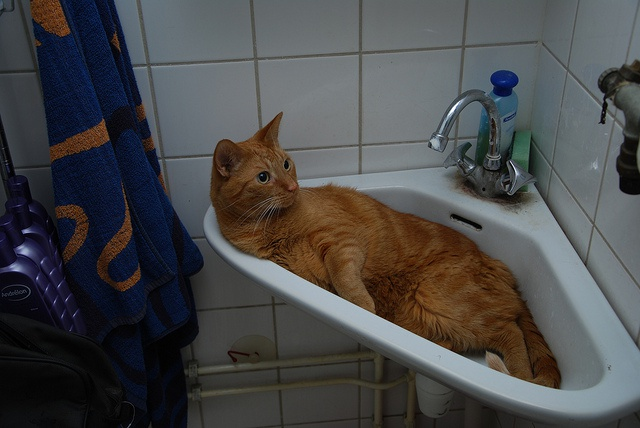Describe the objects in this image and their specific colors. I can see cat in navy, maroon, black, and gray tones and bottle in navy, blue, and black tones in this image. 